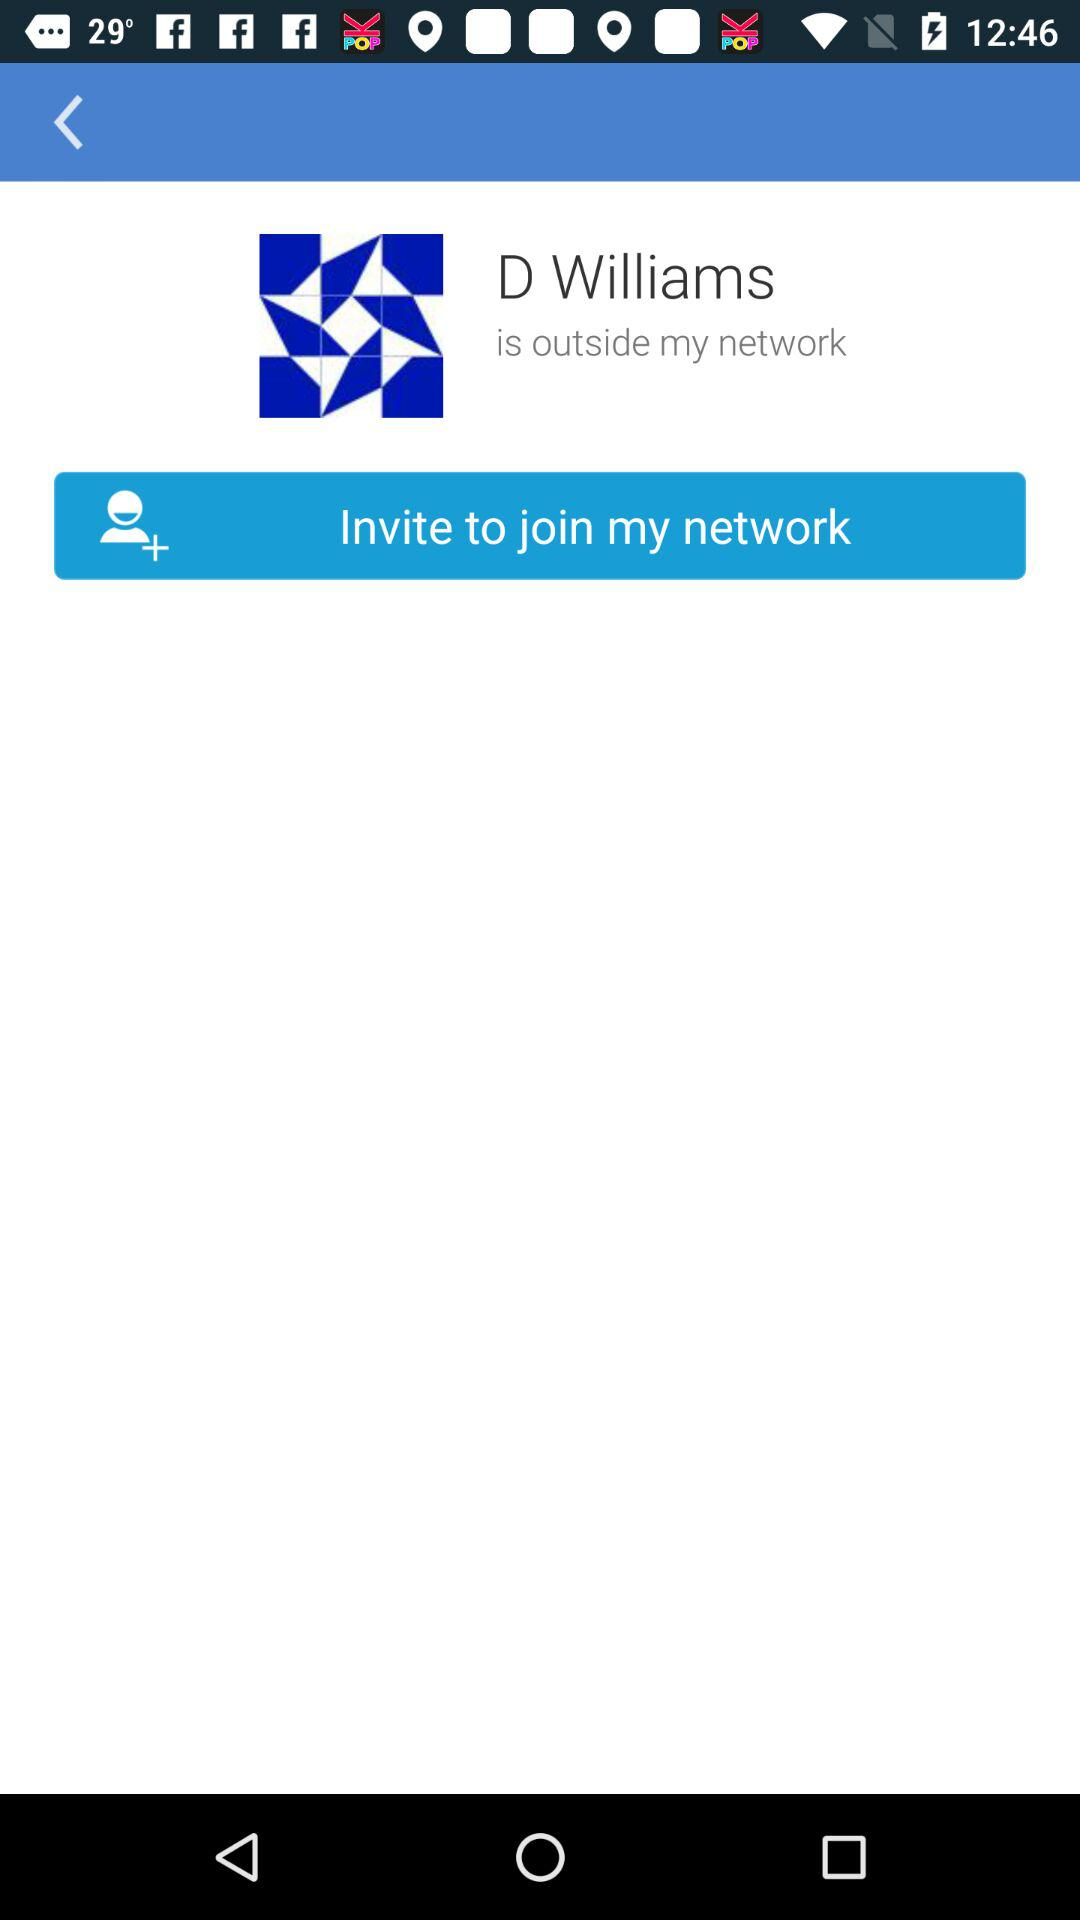What is the name? The name is D Williams. 